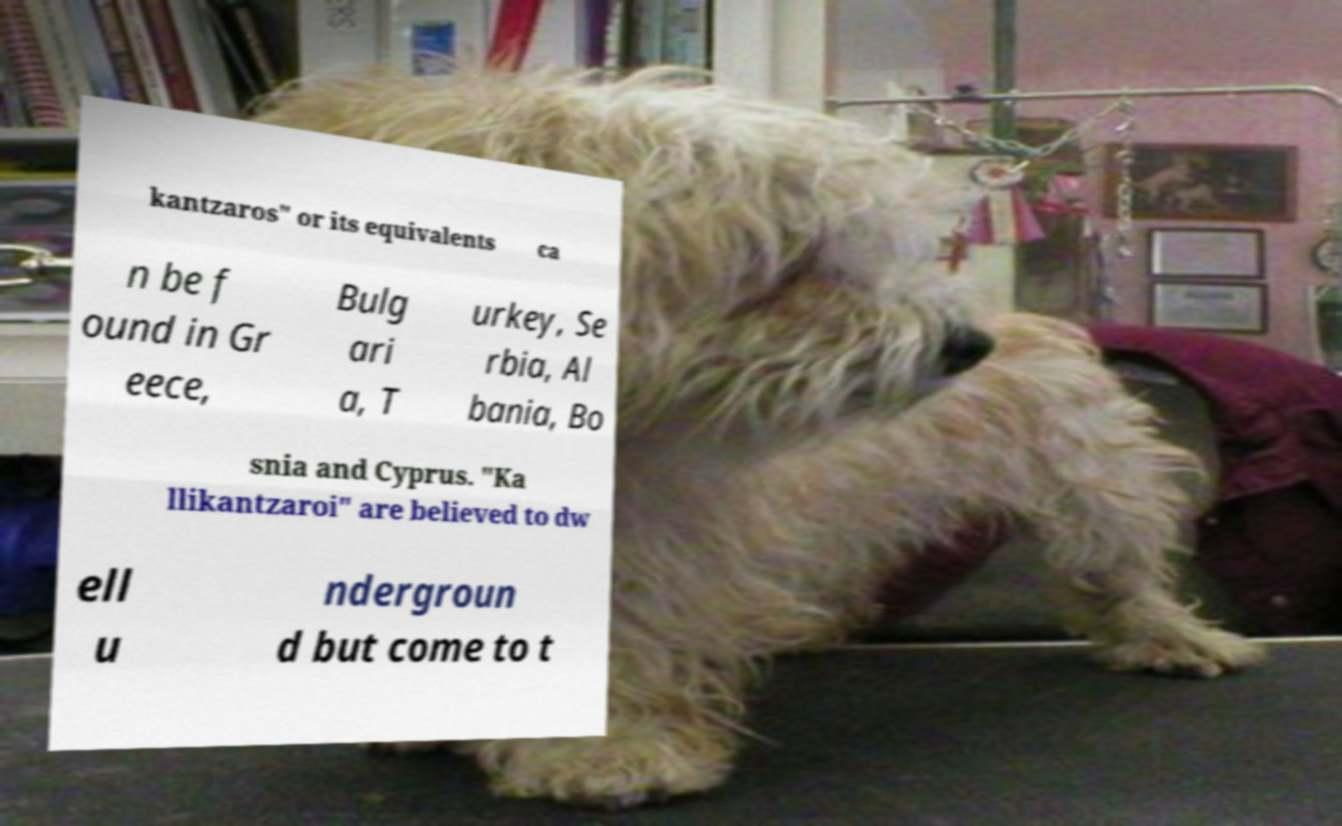Please read and relay the text visible in this image. What does it say? kantzaros" or its equivalents ca n be f ound in Gr eece, Bulg ari a, T urkey, Se rbia, Al bania, Bo snia and Cyprus. "Ka llikantzaroi" are believed to dw ell u ndergroun d but come to t 